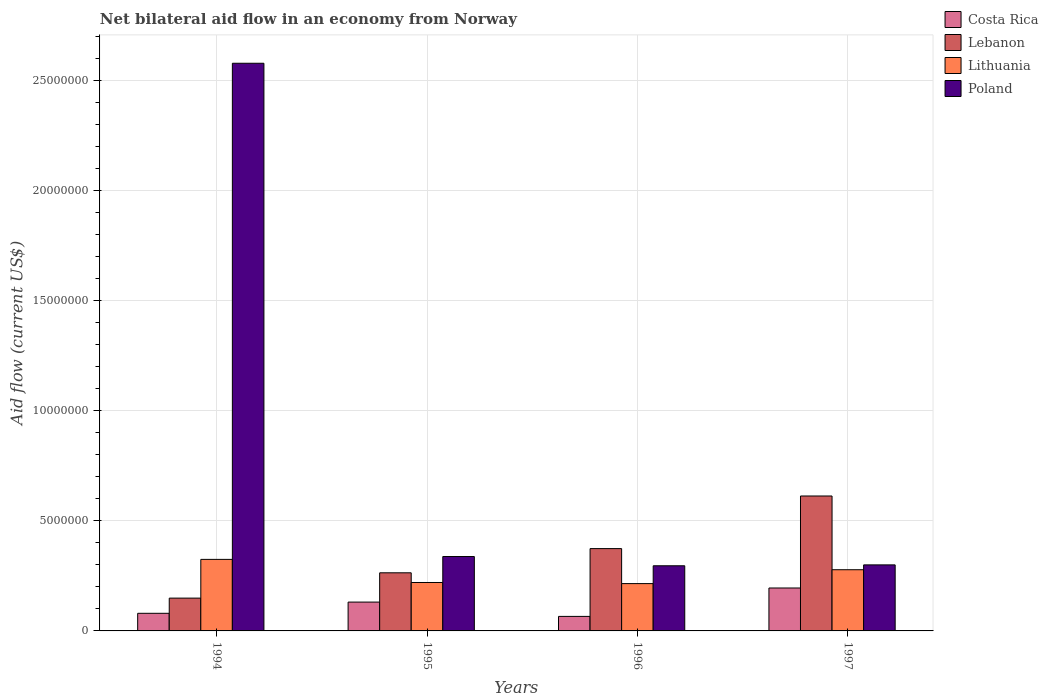How many different coloured bars are there?
Make the answer very short. 4. How many groups of bars are there?
Ensure brevity in your answer.  4. Are the number of bars on each tick of the X-axis equal?
Offer a terse response. Yes. How many bars are there on the 3rd tick from the left?
Keep it short and to the point. 4. What is the label of the 3rd group of bars from the left?
Provide a succinct answer. 1996. Across all years, what is the maximum net bilateral aid flow in Poland?
Provide a succinct answer. 2.58e+07. Across all years, what is the minimum net bilateral aid flow in Lebanon?
Offer a terse response. 1.49e+06. In which year was the net bilateral aid flow in Lebanon minimum?
Your response must be concise. 1994. What is the total net bilateral aid flow in Costa Rica in the graph?
Make the answer very short. 4.72e+06. What is the difference between the net bilateral aid flow in Lithuania in 1996 and that in 1997?
Offer a terse response. -6.30e+05. What is the difference between the net bilateral aid flow in Lebanon in 1994 and the net bilateral aid flow in Lithuania in 1995?
Keep it short and to the point. -7.10e+05. What is the average net bilateral aid flow in Poland per year?
Give a very brief answer. 8.78e+06. What is the ratio of the net bilateral aid flow in Lebanon in 1995 to that in 1997?
Give a very brief answer. 0.43. What is the difference between the highest and the second highest net bilateral aid flow in Costa Rica?
Give a very brief answer. 6.40e+05. What is the difference between the highest and the lowest net bilateral aid flow in Lithuania?
Offer a terse response. 1.10e+06. Is the sum of the net bilateral aid flow in Lithuania in 1994 and 1996 greater than the maximum net bilateral aid flow in Poland across all years?
Your answer should be compact. No. Is it the case that in every year, the sum of the net bilateral aid flow in Poland and net bilateral aid flow in Lebanon is greater than the sum of net bilateral aid flow in Costa Rica and net bilateral aid flow in Lithuania?
Your response must be concise. Yes. What does the 3rd bar from the left in 1994 represents?
Your answer should be very brief. Lithuania. What does the 2nd bar from the right in 1996 represents?
Your answer should be compact. Lithuania. Is it the case that in every year, the sum of the net bilateral aid flow in Lithuania and net bilateral aid flow in Lebanon is greater than the net bilateral aid flow in Poland?
Give a very brief answer. No. How many bars are there?
Your answer should be compact. 16. Does the graph contain any zero values?
Ensure brevity in your answer.  No. Does the graph contain grids?
Make the answer very short. Yes. Where does the legend appear in the graph?
Ensure brevity in your answer.  Top right. How many legend labels are there?
Make the answer very short. 4. How are the legend labels stacked?
Provide a short and direct response. Vertical. What is the title of the graph?
Your answer should be compact. Net bilateral aid flow in an economy from Norway. What is the label or title of the X-axis?
Your response must be concise. Years. What is the label or title of the Y-axis?
Give a very brief answer. Aid flow (current US$). What is the Aid flow (current US$) of Lebanon in 1994?
Your answer should be very brief. 1.49e+06. What is the Aid flow (current US$) of Lithuania in 1994?
Your response must be concise. 3.25e+06. What is the Aid flow (current US$) in Poland in 1994?
Give a very brief answer. 2.58e+07. What is the Aid flow (current US$) of Costa Rica in 1995?
Your answer should be compact. 1.31e+06. What is the Aid flow (current US$) of Lebanon in 1995?
Provide a succinct answer. 2.64e+06. What is the Aid flow (current US$) in Lithuania in 1995?
Ensure brevity in your answer.  2.20e+06. What is the Aid flow (current US$) of Poland in 1995?
Offer a terse response. 3.38e+06. What is the Aid flow (current US$) in Lebanon in 1996?
Your answer should be very brief. 3.74e+06. What is the Aid flow (current US$) in Lithuania in 1996?
Your answer should be compact. 2.15e+06. What is the Aid flow (current US$) of Poland in 1996?
Offer a terse response. 2.96e+06. What is the Aid flow (current US$) in Costa Rica in 1997?
Your response must be concise. 1.95e+06. What is the Aid flow (current US$) of Lebanon in 1997?
Your answer should be very brief. 6.13e+06. What is the Aid flow (current US$) of Lithuania in 1997?
Offer a terse response. 2.78e+06. Across all years, what is the maximum Aid flow (current US$) of Costa Rica?
Provide a short and direct response. 1.95e+06. Across all years, what is the maximum Aid flow (current US$) in Lebanon?
Give a very brief answer. 6.13e+06. Across all years, what is the maximum Aid flow (current US$) in Lithuania?
Your answer should be very brief. 3.25e+06. Across all years, what is the maximum Aid flow (current US$) of Poland?
Offer a very short reply. 2.58e+07. Across all years, what is the minimum Aid flow (current US$) in Lebanon?
Your response must be concise. 1.49e+06. Across all years, what is the minimum Aid flow (current US$) of Lithuania?
Provide a short and direct response. 2.15e+06. Across all years, what is the minimum Aid flow (current US$) of Poland?
Provide a short and direct response. 2.96e+06. What is the total Aid flow (current US$) in Costa Rica in the graph?
Provide a short and direct response. 4.72e+06. What is the total Aid flow (current US$) of Lebanon in the graph?
Offer a terse response. 1.40e+07. What is the total Aid flow (current US$) of Lithuania in the graph?
Provide a short and direct response. 1.04e+07. What is the total Aid flow (current US$) of Poland in the graph?
Give a very brief answer. 3.51e+07. What is the difference between the Aid flow (current US$) in Costa Rica in 1994 and that in 1995?
Keep it short and to the point. -5.10e+05. What is the difference between the Aid flow (current US$) in Lebanon in 1994 and that in 1995?
Offer a terse response. -1.15e+06. What is the difference between the Aid flow (current US$) of Lithuania in 1994 and that in 1995?
Provide a succinct answer. 1.05e+06. What is the difference between the Aid flow (current US$) of Poland in 1994 and that in 1995?
Provide a short and direct response. 2.24e+07. What is the difference between the Aid flow (current US$) of Costa Rica in 1994 and that in 1996?
Make the answer very short. 1.40e+05. What is the difference between the Aid flow (current US$) in Lebanon in 1994 and that in 1996?
Ensure brevity in your answer.  -2.25e+06. What is the difference between the Aid flow (current US$) of Lithuania in 1994 and that in 1996?
Provide a short and direct response. 1.10e+06. What is the difference between the Aid flow (current US$) of Poland in 1994 and that in 1996?
Provide a short and direct response. 2.28e+07. What is the difference between the Aid flow (current US$) in Costa Rica in 1994 and that in 1997?
Provide a succinct answer. -1.15e+06. What is the difference between the Aid flow (current US$) of Lebanon in 1994 and that in 1997?
Your answer should be very brief. -4.64e+06. What is the difference between the Aid flow (current US$) in Poland in 1994 and that in 1997?
Offer a terse response. 2.28e+07. What is the difference between the Aid flow (current US$) of Costa Rica in 1995 and that in 1996?
Give a very brief answer. 6.50e+05. What is the difference between the Aid flow (current US$) of Lebanon in 1995 and that in 1996?
Provide a short and direct response. -1.10e+06. What is the difference between the Aid flow (current US$) in Lithuania in 1995 and that in 1996?
Ensure brevity in your answer.  5.00e+04. What is the difference between the Aid flow (current US$) of Poland in 1995 and that in 1996?
Your answer should be compact. 4.20e+05. What is the difference between the Aid flow (current US$) in Costa Rica in 1995 and that in 1997?
Offer a very short reply. -6.40e+05. What is the difference between the Aid flow (current US$) in Lebanon in 1995 and that in 1997?
Offer a very short reply. -3.49e+06. What is the difference between the Aid flow (current US$) of Lithuania in 1995 and that in 1997?
Keep it short and to the point. -5.80e+05. What is the difference between the Aid flow (current US$) in Costa Rica in 1996 and that in 1997?
Make the answer very short. -1.29e+06. What is the difference between the Aid flow (current US$) in Lebanon in 1996 and that in 1997?
Keep it short and to the point. -2.39e+06. What is the difference between the Aid flow (current US$) in Lithuania in 1996 and that in 1997?
Offer a very short reply. -6.30e+05. What is the difference between the Aid flow (current US$) in Poland in 1996 and that in 1997?
Ensure brevity in your answer.  -4.00e+04. What is the difference between the Aid flow (current US$) of Costa Rica in 1994 and the Aid flow (current US$) of Lebanon in 1995?
Give a very brief answer. -1.84e+06. What is the difference between the Aid flow (current US$) of Costa Rica in 1994 and the Aid flow (current US$) of Lithuania in 1995?
Give a very brief answer. -1.40e+06. What is the difference between the Aid flow (current US$) of Costa Rica in 1994 and the Aid flow (current US$) of Poland in 1995?
Offer a very short reply. -2.58e+06. What is the difference between the Aid flow (current US$) in Lebanon in 1994 and the Aid flow (current US$) in Lithuania in 1995?
Give a very brief answer. -7.10e+05. What is the difference between the Aid flow (current US$) of Lebanon in 1994 and the Aid flow (current US$) of Poland in 1995?
Offer a terse response. -1.89e+06. What is the difference between the Aid flow (current US$) of Lithuania in 1994 and the Aid flow (current US$) of Poland in 1995?
Your answer should be very brief. -1.30e+05. What is the difference between the Aid flow (current US$) in Costa Rica in 1994 and the Aid flow (current US$) in Lebanon in 1996?
Provide a succinct answer. -2.94e+06. What is the difference between the Aid flow (current US$) of Costa Rica in 1994 and the Aid flow (current US$) of Lithuania in 1996?
Give a very brief answer. -1.35e+06. What is the difference between the Aid flow (current US$) of Costa Rica in 1994 and the Aid flow (current US$) of Poland in 1996?
Give a very brief answer. -2.16e+06. What is the difference between the Aid flow (current US$) of Lebanon in 1994 and the Aid flow (current US$) of Lithuania in 1996?
Provide a succinct answer. -6.60e+05. What is the difference between the Aid flow (current US$) of Lebanon in 1994 and the Aid flow (current US$) of Poland in 1996?
Provide a succinct answer. -1.47e+06. What is the difference between the Aid flow (current US$) in Costa Rica in 1994 and the Aid flow (current US$) in Lebanon in 1997?
Provide a succinct answer. -5.33e+06. What is the difference between the Aid flow (current US$) of Costa Rica in 1994 and the Aid flow (current US$) of Lithuania in 1997?
Your answer should be very brief. -1.98e+06. What is the difference between the Aid flow (current US$) in Costa Rica in 1994 and the Aid flow (current US$) in Poland in 1997?
Provide a short and direct response. -2.20e+06. What is the difference between the Aid flow (current US$) in Lebanon in 1994 and the Aid flow (current US$) in Lithuania in 1997?
Your answer should be compact. -1.29e+06. What is the difference between the Aid flow (current US$) in Lebanon in 1994 and the Aid flow (current US$) in Poland in 1997?
Keep it short and to the point. -1.51e+06. What is the difference between the Aid flow (current US$) of Lithuania in 1994 and the Aid flow (current US$) of Poland in 1997?
Give a very brief answer. 2.50e+05. What is the difference between the Aid flow (current US$) of Costa Rica in 1995 and the Aid flow (current US$) of Lebanon in 1996?
Give a very brief answer. -2.43e+06. What is the difference between the Aid flow (current US$) in Costa Rica in 1995 and the Aid flow (current US$) in Lithuania in 1996?
Give a very brief answer. -8.40e+05. What is the difference between the Aid flow (current US$) in Costa Rica in 1995 and the Aid flow (current US$) in Poland in 1996?
Provide a short and direct response. -1.65e+06. What is the difference between the Aid flow (current US$) of Lebanon in 1995 and the Aid flow (current US$) of Poland in 1996?
Your response must be concise. -3.20e+05. What is the difference between the Aid flow (current US$) of Lithuania in 1995 and the Aid flow (current US$) of Poland in 1996?
Your answer should be compact. -7.60e+05. What is the difference between the Aid flow (current US$) in Costa Rica in 1995 and the Aid flow (current US$) in Lebanon in 1997?
Keep it short and to the point. -4.82e+06. What is the difference between the Aid flow (current US$) in Costa Rica in 1995 and the Aid flow (current US$) in Lithuania in 1997?
Your response must be concise. -1.47e+06. What is the difference between the Aid flow (current US$) of Costa Rica in 1995 and the Aid flow (current US$) of Poland in 1997?
Keep it short and to the point. -1.69e+06. What is the difference between the Aid flow (current US$) of Lebanon in 1995 and the Aid flow (current US$) of Lithuania in 1997?
Your answer should be very brief. -1.40e+05. What is the difference between the Aid flow (current US$) of Lebanon in 1995 and the Aid flow (current US$) of Poland in 1997?
Your response must be concise. -3.60e+05. What is the difference between the Aid flow (current US$) of Lithuania in 1995 and the Aid flow (current US$) of Poland in 1997?
Your answer should be compact. -8.00e+05. What is the difference between the Aid flow (current US$) in Costa Rica in 1996 and the Aid flow (current US$) in Lebanon in 1997?
Offer a terse response. -5.47e+06. What is the difference between the Aid flow (current US$) in Costa Rica in 1996 and the Aid flow (current US$) in Lithuania in 1997?
Provide a short and direct response. -2.12e+06. What is the difference between the Aid flow (current US$) in Costa Rica in 1996 and the Aid flow (current US$) in Poland in 1997?
Your answer should be compact. -2.34e+06. What is the difference between the Aid flow (current US$) in Lebanon in 1996 and the Aid flow (current US$) in Lithuania in 1997?
Provide a short and direct response. 9.60e+05. What is the difference between the Aid flow (current US$) of Lebanon in 1996 and the Aid flow (current US$) of Poland in 1997?
Offer a terse response. 7.40e+05. What is the difference between the Aid flow (current US$) in Lithuania in 1996 and the Aid flow (current US$) in Poland in 1997?
Your answer should be very brief. -8.50e+05. What is the average Aid flow (current US$) in Costa Rica per year?
Offer a terse response. 1.18e+06. What is the average Aid flow (current US$) in Lebanon per year?
Your response must be concise. 3.50e+06. What is the average Aid flow (current US$) of Lithuania per year?
Give a very brief answer. 2.60e+06. What is the average Aid flow (current US$) in Poland per year?
Offer a terse response. 8.78e+06. In the year 1994, what is the difference between the Aid flow (current US$) of Costa Rica and Aid flow (current US$) of Lebanon?
Your answer should be compact. -6.90e+05. In the year 1994, what is the difference between the Aid flow (current US$) in Costa Rica and Aid flow (current US$) in Lithuania?
Your answer should be compact. -2.45e+06. In the year 1994, what is the difference between the Aid flow (current US$) of Costa Rica and Aid flow (current US$) of Poland?
Offer a terse response. -2.50e+07. In the year 1994, what is the difference between the Aid flow (current US$) in Lebanon and Aid flow (current US$) in Lithuania?
Make the answer very short. -1.76e+06. In the year 1994, what is the difference between the Aid flow (current US$) of Lebanon and Aid flow (current US$) of Poland?
Your response must be concise. -2.43e+07. In the year 1994, what is the difference between the Aid flow (current US$) of Lithuania and Aid flow (current US$) of Poland?
Give a very brief answer. -2.25e+07. In the year 1995, what is the difference between the Aid flow (current US$) in Costa Rica and Aid flow (current US$) in Lebanon?
Your answer should be compact. -1.33e+06. In the year 1995, what is the difference between the Aid flow (current US$) of Costa Rica and Aid flow (current US$) of Lithuania?
Your response must be concise. -8.90e+05. In the year 1995, what is the difference between the Aid flow (current US$) in Costa Rica and Aid flow (current US$) in Poland?
Give a very brief answer. -2.07e+06. In the year 1995, what is the difference between the Aid flow (current US$) in Lebanon and Aid flow (current US$) in Poland?
Keep it short and to the point. -7.40e+05. In the year 1995, what is the difference between the Aid flow (current US$) of Lithuania and Aid flow (current US$) of Poland?
Offer a terse response. -1.18e+06. In the year 1996, what is the difference between the Aid flow (current US$) of Costa Rica and Aid flow (current US$) of Lebanon?
Your answer should be compact. -3.08e+06. In the year 1996, what is the difference between the Aid flow (current US$) in Costa Rica and Aid flow (current US$) in Lithuania?
Make the answer very short. -1.49e+06. In the year 1996, what is the difference between the Aid flow (current US$) in Costa Rica and Aid flow (current US$) in Poland?
Ensure brevity in your answer.  -2.30e+06. In the year 1996, what is the difference between the Aid flow (current US$) in Lebanon and Aid flow (current US$) in Lithuania?
Ensure brevity in your answer.  1.59e+06. In the year 1996, what is the difference between the Aid flow (current US$) of Lebanon and Aid flow (current US$) of Poland?
Make the answer very short. 7.80e+05. In the year 1996, what is the difference between the Aid flow (current US$) of Lithuania and Aid flow (current US$) of Poland?
Offer a terse response. -8.10e+05. In the year 1997, what is the difference between the Aid flow (current US$) of Costa Rica and Aid flow (current US$) of Lebanon?
Your response must be concise. -4.18e+06. In the year 1997, what is the difference between the Aid flow (current US$) of Costa Rica and Aid flow (current US$) of Lithuania?
Ensure brevity in your answer.  -8.30e+05. In the year 1997, what is the difference between the Aid flow (current US$) of Costa Rica and Aid flow (current US$) of Poland?
Make the answer very short. -1.05e+06. In the year 1997, what is the difference between the Aid flow (current US$) in Lebanon and Aid flow (current US$) in Lithuania?
Keep it short and to the point. 3.35e+06. In the year 1997, what is the difference between the Aid flow (current US$) of Lebanon and Aid flow (current US$) of Poland?
Offer a very short reply. 3.13e+06. What is the ratio of the Aid flow (current US$) in Costa Rica in 1994 to that in 1995?
Give a very brief answer. 0.61. What is the ratio of the Aid flow (current US$) in Lebanon in 1994 to that in 1995?
Offer a terse response. 0.56. What is the ratio of the Aid flow (current US$) in Lithuania in 1994 to that in 1995?
Give a very brief answer. 1.48. What is the ratio of the Aid flow (current US$) in Poland in 1994 to that in 1995?
Offer a terse response. 7.63. What is the ratio of the Aid flow (current US$) in Costa Rica in 1994 to that in 1996?
Your answer should be compact. 1.21. What is the ratio of the Aid flow (current US$) of Lebanon in 1994 to that in 1996?
Make the answer very short. 0.4. What is the ratio of the Aid flow (current US$) in Lithuania in 1994 to that in 1996?
Make the answer very short. 1.51. What is the ratio of the Aid flow (current US$) of Poland in 1994 to that in 1996?
Provide a succinct answer. 8.71. What is the ratio of the Aid flow (current US$) of Costa Rica in 1994 to that in 1997?
Your response must be concise. 0.41. What is the ratio of the Aid flow (current US$) in Lebanon in 1994 to that in 1997?
Your response must be concise. 0.24. What is the ratio of the Aid flow (current US$) in Lithuania in 1994 to that in 1997?
Provide a succinct answer. 1.17. What is the ratio of the Aid flow (current US$) in Poland in 1994 to that in 1997?
Your answer should be compact. 8.6. What is the ratio of the Aid flow (current US$) in Costa Rica in 1995 to that in 1996?
Give a very brief answer. 1.98. What is the ratio of the Aid flow (current US$) in Lebanon in 1995 to that in 1996?
Provide a short and direct response. 0.71. What is the ratio of the Aid flow (current US$) in Lithuania in 1995 to that in 1996?
Give a very brief answer. 1.02. What is the ratio of the Aid flow (current US$) in Poland in 1995 to that in 1996?
Provide a succinct answer. 1.14. What is the ratio of the Aid flow (current US$) of Costa Rica in 1995 to that in 1997?
Make the answer very short. 0.67. What is the ratio of the Aid flow (current US$) in Lebanon in 1995 to that in 1997?
Make the answer very short. 0.43. What is the ratio of the Aid flow (current US$) of Lithuania in 1995 to that in 1997?
Your answer should be very brief. 0.79. What is the ratio of the Aid flow (current US$) in Poland in 1995 to that in 1997?
Your answer should be compact. 1.13. What is the ratio of the Aid flow (current US$) in Costa Rica in 1996 to that in 1997?
Keep it short and to the point. 0.34. What is the ratio of the Aid flow (current US$) of Lebanon in 1996 to that in 1997?
Your response must be concise. 0.61. What is the ratio of the Aid flow (current US$) in Lithuania in 1996 to that in 1997?
Offer a very short reply. 0.77. What is the ratio of the Aid flow (current US$) of Poland in 1996 to that in 1997?
Offer a terse response. 0.99. What is the difference between the highest and the second highest Aid flow (current US$) of Costa Rica?
Give a very brief answer. 6.40e+05. What is the difference between the highest and the second highest Aid flow (current US$) of Lebanon?
Your answer should be compact. 2.39e+06. What is the difference between the highest and the second highest Aid flow (current US$) in Poland?
Offer a very short reply. 2.24e+07. What is the difference between the highest and the lowest Aid flow (current US$) in Costa Rica?
Make the answer very short. 1.29e+06. What is the difference between the highest and the lowest Aid flow (current US$) of Lebanon?
Keep it short and to the point. 4.64e+06. What is the difference between the highest and the lowest Aid flow (current US$) of Lithuania?
Offer a very short reply. 1.10e+06. What is the difference between the highest and the lowest Aid flow (current US$) in Poland?
Your answer should be very brief. 2.28e+07. 